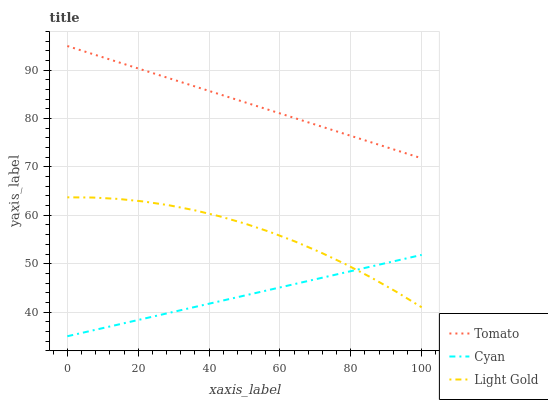Does Cyan have the minimum area under the curve?
Answer yes or no. Yes. Does Tomato have the maximum area under the curve?
Answer yes or no. Yes. Does Light Gold have the minimum area under the curve?
Answer yes or no. No. Does Light Gold have the maximum area under the curve?
Answer yes or no. No. Is Cyan the smoothest?
Answer yes or no. Yes. Is Light Gold the roughest?
Answer yes or no. Yes. Is Light Gold the smoothest?
Answer yes or no. No. Is Cyan the roughest?
Answer yes or no. No. Does Cyan have the lowest value?
Answer yes or no. Yes. Does Light Gold have the lowest value?
Answer yes or no. No. Does Tomato have the highest value?
Answer yes or no. Yes. Does Light Gold have the highest value?
Answer yes or no. No. Is Cyan less than Tomato?
Answer yes or no. Yes. Is Tomato greater than Light Gold?
Answer yes or no. Yes. Does Cyan intersect Light Gold?
Answer yes or no. Yes. Is Cyan less than Light Gold?
Answer yes or no. No. Is Cyan greater than Light Gold?
Answer yes or no. No. Does Cyan intersect Tomato?
Answer yes or no. No. 